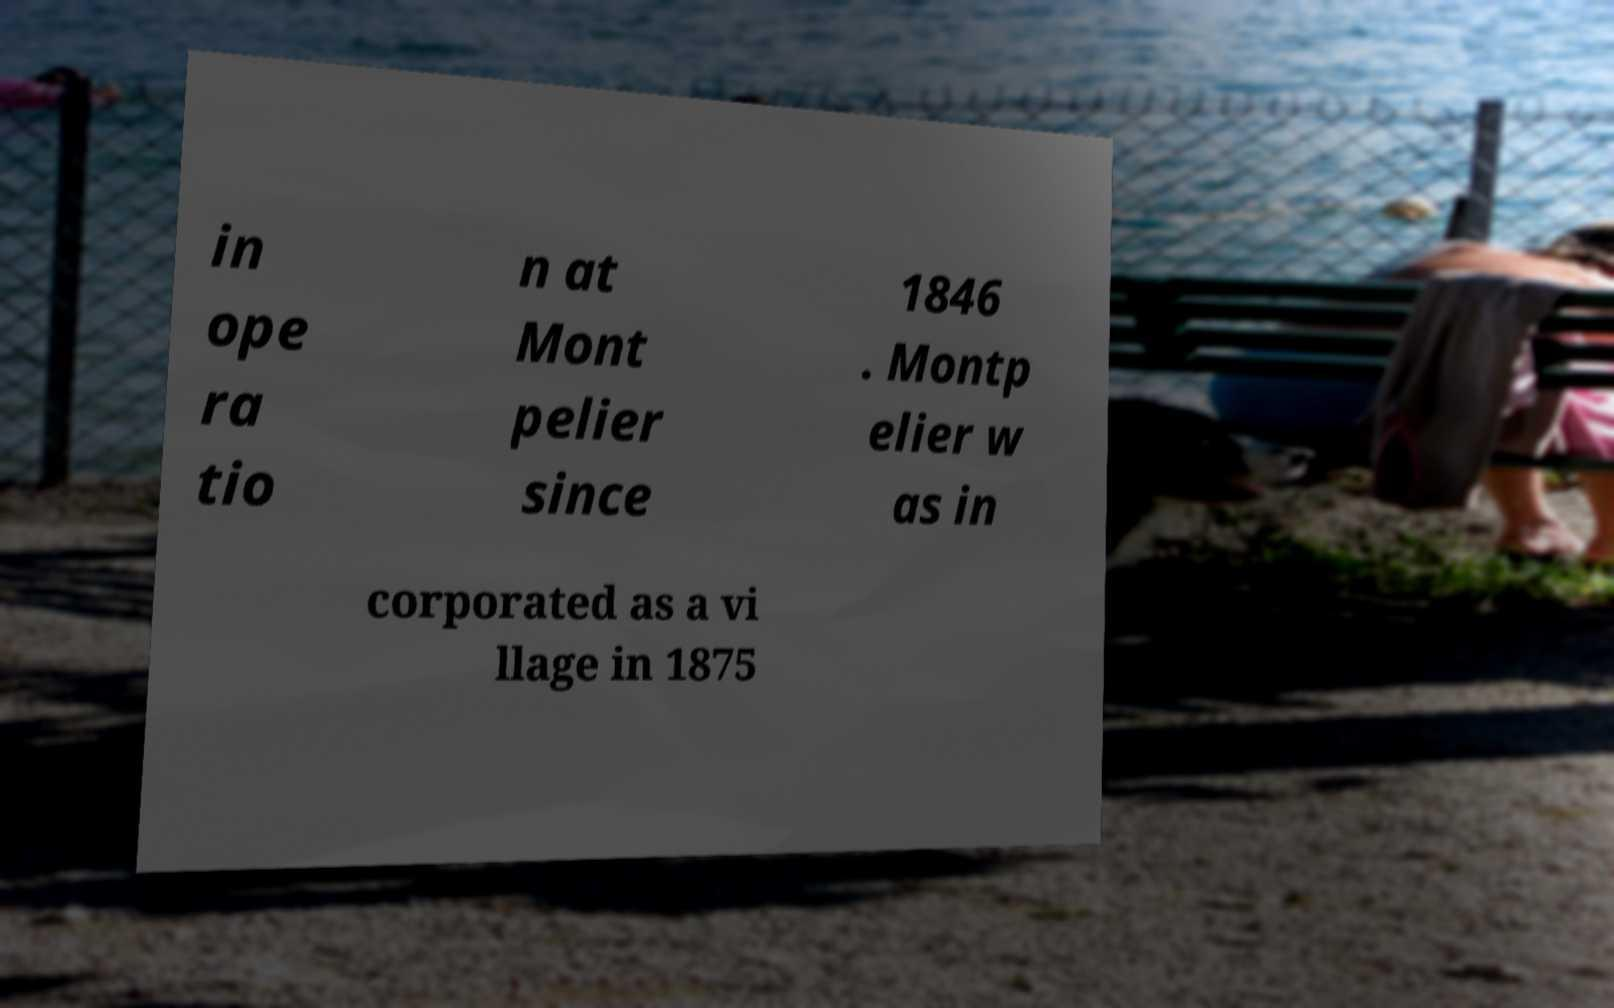Could you assist in decoding the text presented in this image and type it out clearly? in ope ra tio n at Mont pelier since 1846 . Montp elier w as in corporated as a vi llage in 1875 